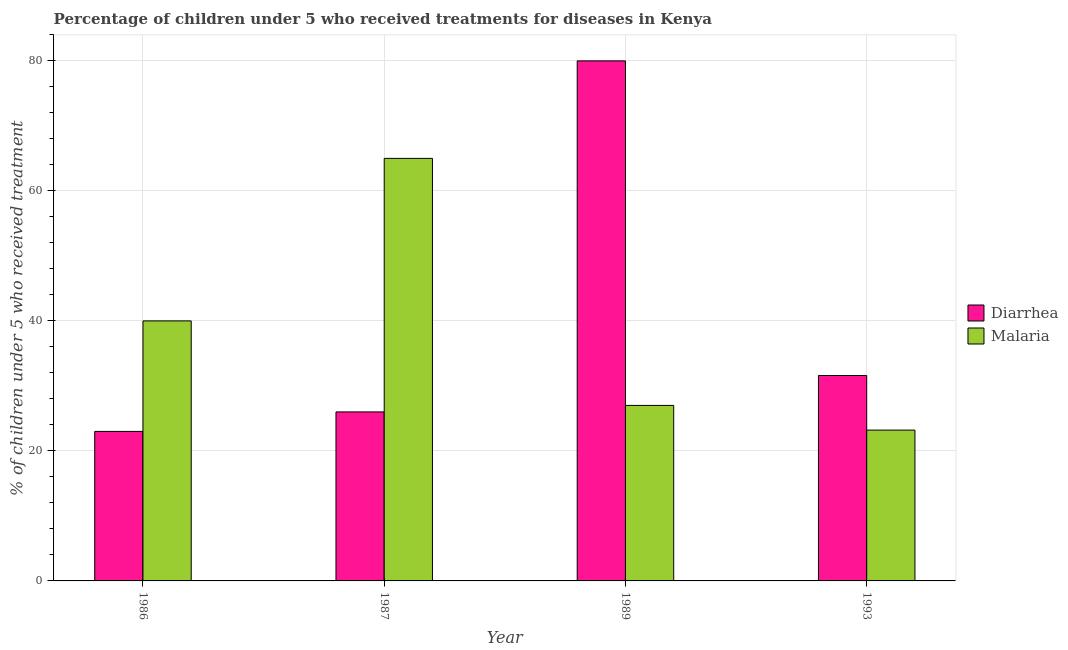How many different coloured bars are there?
Offer a terse response. 2. Are the number of bars per tick equal to the number of legend labels?
Offer a very short reply. Yes. How many bars are there on the 2nd tick from the left?
Give a very brief answer. 2. How many bars are there on the 2nd tick from the right?
Your answer should be compact. 2. What is the label of the 1st group of bars from the left?
Give a very brief answer. 1986. In how many cases, is the number of bars for a given year not equal to the number of legend labels?
Offer a terse response. 0. Across all years, what is the maximum percentage of children who received treatment for diarrhoea?
Your answer should be compact. 80. Across all years, what is the minimum percentage of children who received treatment for malaria?
Provide a succinct answer. 23.2. What is the total percentage of children who received treatment for malaria in the graph?
Provide a short and direct response. 155.2. What is the difference between the percentage of children who received treatment for malaria in 1986 and the percentage of children who received treatment for diarrhoea in 1989?
Your answer should be compact. 13. What is the average percentage of children who received treatment for malaria per year?
Your answer should be very brief. 38.8. What is the ratio of the percentage of children who received treatment for malaria in 1987 to that in 1993?
Ensure brevity in your answer.  2.8. Is the percentage of children who received treatment for diarrhoea in 1986 less than that in 1993?
Provide a short and direct response. Yes. Is the difference between the percentage of children who received treatment for malaria in 1986 and 1993 greater than the difference between the percentage of children who received treatment for diarrhoea in 1986 and 1993?
Ensure brevity in your answer.  No. What is the difference between the highest and the second highest percentage of children who received treatment for malaria?
Keep it short and to the point. 25. What is the difference between the highest and the lowest percentage of children who received treatment for diarrhoea?
Provide a short and direct response. 57. In how many years, is the percentage of children who received treatment for malaria greater than the average percentage of children who received treatment for malaria taken over all years?
Give a very brief answer. 2. What does the 1st bar from the left in 1989 represents?
Give a very brief answer. Diarrhea. What does the 1st bar from the right in 1987 represents?
Provide a short and direct response. Malaria. How many bars are there?
Provide a succinct answer. 8. How many years are there in the graph?
Your response must be concise. 4. What is the difference between two consecutive major ticks on the Y-axis?
Offer a terse response. 20. Are the values on the major ticks of Y-axis written in scientific E-notation?
Your response must be concise. No. Does the graph contain grids?
Ensure brevity in your answer.  Yes. Where does the legend appear in the graph?
Provide a short and direct response. Center right. How many legend labels are there?
Provide a short and direct response. 2. How are the legend labels stacked?
Give a very brief answer. Vertical. What is the title of the graph?
Keep it short and to the point. Percentage of children under 5 who received treatments for diseases in Kenya. Does "From World Bank" appear as one of the legend labels in the graph?
Offer a very short reply. No. What is the label or title of the Y-axis?
Ensure brevity in your answer.  % of children under 5 who received treatment. What is the % of children under 5 who received treatment of Diarrhea in 1987?
Your answer should be very brief. 26. What is the % of children under 5 who received treatment of Malaria in 1987?
Give a very brief answer. 65. What is the % of children under 5 who received treatment of Malaria in 1989?
Make the answer very short. 27. What is the % of children under 5 who received treatment in Diarrhea in 1993?
Offer a terse response. 31.6. What is the % of children under 5 who received treatment in Malaria in 1993?
Give a very brief answer. 23.2. Across all years, what is the maximum % of children under 5 who received treatment in Malaria?
Give a very brief answer. 65. Across all years, what is the minimum % of children under 5 who received treatment of Malaria?
Your answer should be compact. 23.2. What is the total % of children under 5 who received treatment in Diarrhea in the graph?
Offer a terse response. 160.6. What is the total % of children under 5 who received treatment in Malaria in the graph?
Your answer should be compact. 155.2. What is the difference between the % of children under 5 who received treatment in Diarrhea in 1986 and that in 1987?
Your response must be concise. -3. What is the difference between the % of children under 5 who received treatment of Malaria in 1986 and that in 1987?
Provide a short and direct response. -25. What is the difference between the % of children under 5 who received treatment of Diarrhea in 1986 and that in 1989?
Offer a very short reply. -57. What is the difference between the % of children under 5 who received treatment of Diarrhea in 1986 and that in 1993?
Keep it short and to the point. -8.6. What is the difference between the % of children under 5 who received treatment in Malaria in 1986 and that in 1993?
Give a very brief answer. 16.8. What is the difference between the % of children under 5 who received treatment in Diarrhea in 1987 and that in 1989?
Keep it short and to the point. -54. What is the difference between the % of children under 5 who received treatment of Diarrhea in 1987 and that in 1993?
Your answer should be compact. -5.6. What is the difference between the % of children under 5 who received treatment in Malaria in 1987 and that in 1993?
Your answer should be very brief. 41.8. What is the difference between the % of children under 5 who received treatment of Diarrhea in 1989 and that in 1993?
Make the answer very short. 48.4. What is the difference between the % of children under 5 who received treatment in Malaria in 1989 and that in 1993?
Your response must be concise. 3.8. What is the difference between the % of children under 5 who received treatment of Diarrhea in 1986 and the % of children under 5 who received treatment of Malaria in 1987?
Ensure brevity in your answer.  -42. What is the difference between the % of children under 5 who received treatment in Diarrhea in 1987 and the % of children under 5 who received treatment in Malaria in 1993?
Your answer should be very brief. 2.8. What is the difference between the % of children under 5 who received treatment of Diarrhea in 1989 and the % of children under 5 who received treatment of Malaria in 1993?
Provide a succinct answer. 56.8. What is the average % of children under 5 who received treatment in Diarrhea per year?
Provide a succinct answer. 40.15. What is the average % of children under 5 who received treatment of Malaria per year?
Give a very brief answer. 38.8. In the year 1986, what is the difference between the % of children under 5 who received treatment in Diarrhea and % of children under 5 who received treatment in Malaria?
Make the answer very short. -17. In the year 1987, what is the difference between the % of children under 5 who received treatment of Diarrhea and % of children under 5 who received treatment of Malaria?
Offer a terse response. -39. In the year 1993, what is the difference between the % of children under 5 who received treatment in Diarrhea and % of children under 5 who received treatment in Malaria?
Offer a terse response. 8.4. What is the ratio of the % of children under 5 who received treatment of Diarrhea in 1986 to that in 1987?
Your answer should be compact. 0.88. What is the ratio of the % of children under 5 who received treatment of Malaria in 1986 to that in 1987?
Your answer should be very brief. 0.62. What is the ratio of the % of children under 5 who received treatment in Diarrhea in 1986 to that in 1989?
Your response must be concise. 0.29. What is the ratio of the % of children under 5 who received treatment in Malaria in 1986 to that in 1989?
Give a very brief answer. 1.48. What is the ratio of the % of children under 5 who received treatment in Diarrhea in 1986 to that in 1993?
Make the answer very short. 0.73. What is the ratio of the % of children under 5 who received treatment in Malaria in 1986 to that in 1993?
Provide a short and direct response. 1.72. What is the ratio of the % of children under 5 who received treatment in Diarrhea in 1987 to that in 1989?
Provide a short and direct response. 0.33. What is the ratio of the % of children under 5 who received treatment in Malaria in 1987 to that in 1989?
Your response must be concise. 2.41. What is the ratio of the % of children under 5 who received treatment in Diarrhea in 1987 to that in 1993?
Provide a short and direct response. 0.82. What is the ratio of the % of children under 5 who received treatment of Malaria in 1987 to that in 1993?
Give a very brief answer. 2.8. What is the ratio of the % of children under 5 who received treatment in Diarrhea in 1989 to that in 1993?
Your response must be concise. 2.53. What is the ratio of the % of children under 5 who received treatment of Malaria in 1989 to that in 1993?
Keep it short and to the point. 1.16. What is the difference between the highest and the second highest % of children under 5 who received treatment in Diarrhea?
Provide a succinct answer. 48.4. What is the difference between the highest and the lowest % of children under 5 who received treatment of Diarrhea?
Your answer should be very brief. 57. What is the difference between the highest and the lowest % of children under 5 who received treatment of Malaria?
Keep it short and to the point. 41.8. 